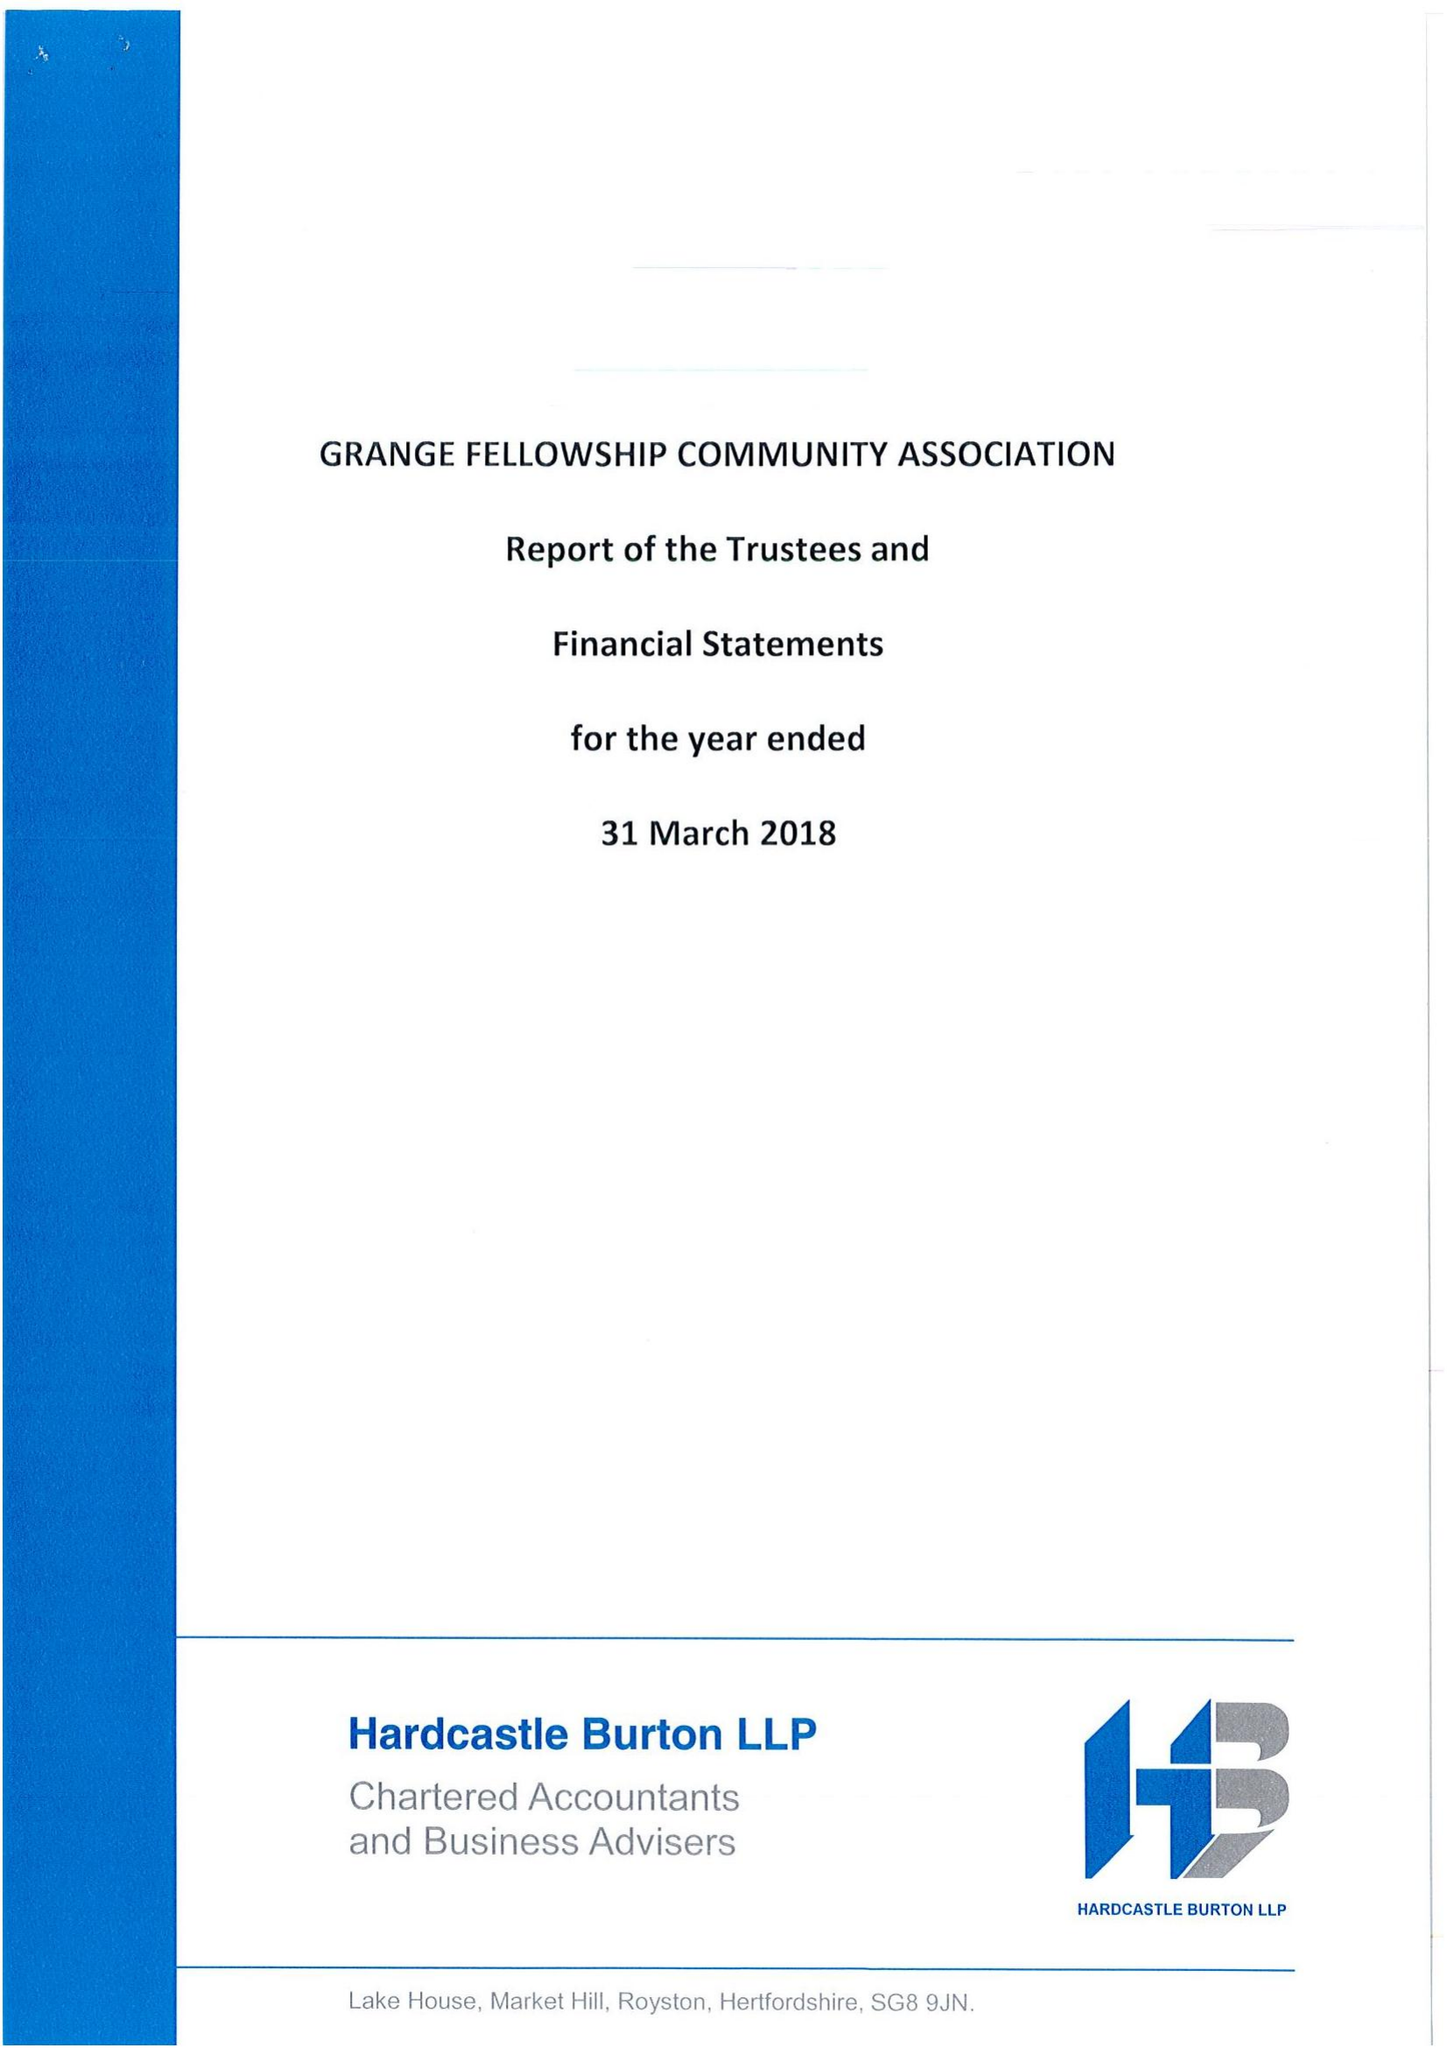What is the value for the charity_name?
Answer the question using a single word or phrase. Grange Fellowship Community Association 